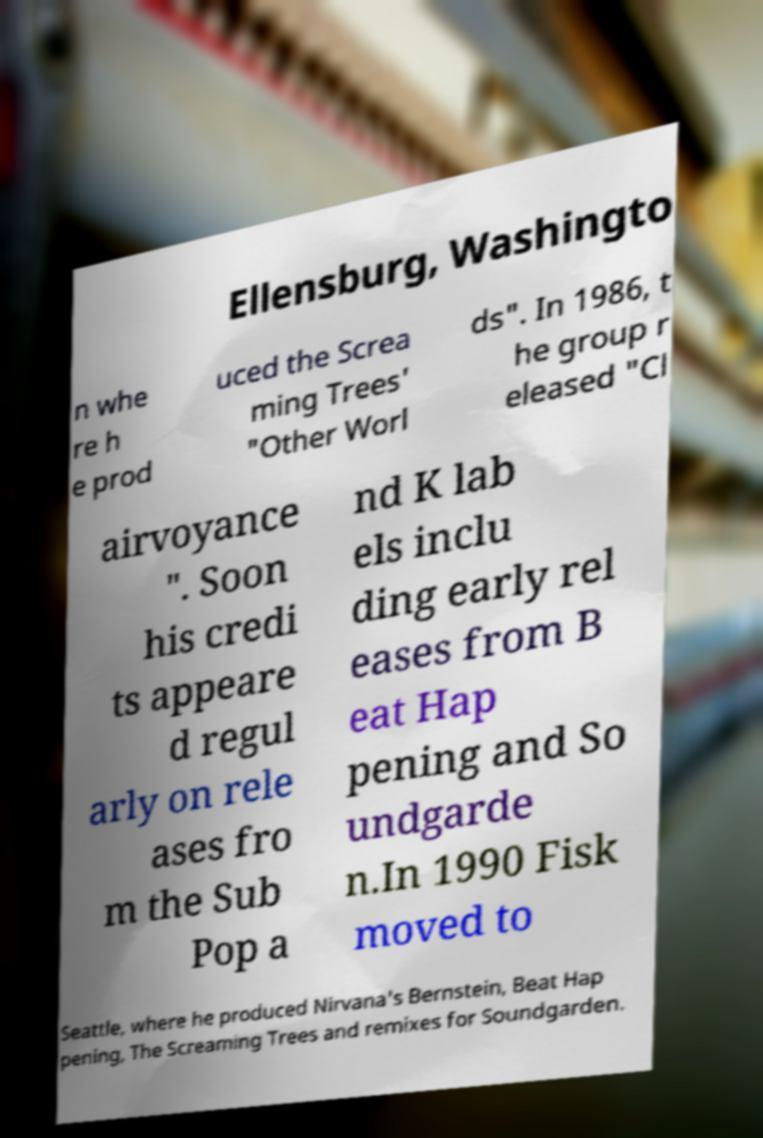Can you read and provide the text displayed in the image?This photo seems to have some interesting text. Can you extract and type it out for me? Ellensburg, Washingto n whe re h e prod uced the Screa ming Trees' "Other Worl ds". In 1986, t he group r eleased "Cl airvoyance ". Soon his credi ts appeare d regul arly on rele ases fro m the Sub Pop a nd K lab els inclu ding early rel eases from B eat Hap pening and So undgarde n.In 1990 Fisk moved to Seattle, where he produced Nirvana's Bernstein, Beat Hap pening, The Screaming Trees and remixes for Soundgarden. 